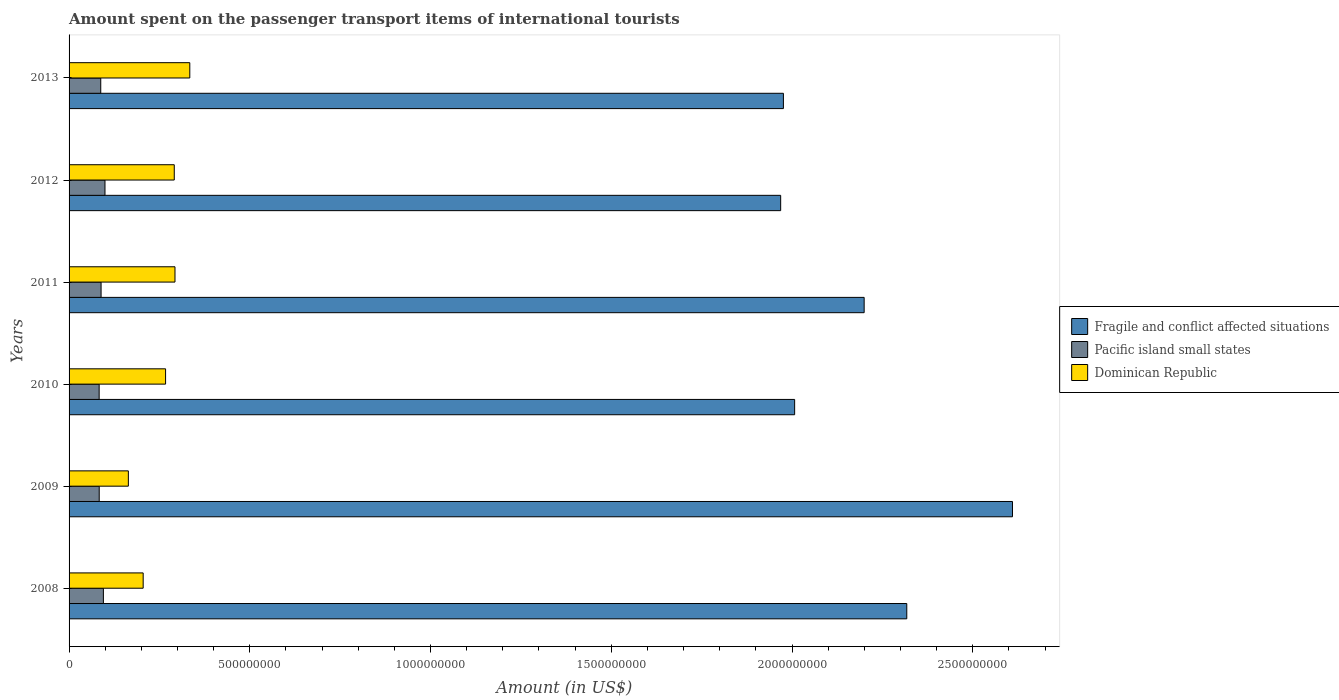How many different coloured bars are there?
Keep it short and to the point. 3. How many groups of bars are there?
Offer a terse response. 6. Are the number of bars per tick equal to the number of legend labels?
Provide a succinct answer. Yes. Are the number of bars on each tick of the Y-axis equal?
Ensure brevity in your answer.  Yes. How many bars are there on the 6th tick from the top?
Keep it short and to the point. 3. What is the label of the 3rd group of bars from the top?
Make the answer very short. 2011. In how many cases, is the number of bars for a given year not equal to the number of legend labels?
Make the answer very short. 0. What is the amount spent on the passenger transport items of international tourists in Pacific island small states in 2012?
Ensure brevity in your answer.  9.93e+07. Across all years, what is the maximum amount spent on the passenger transport items of international tourists in Pacific island small states?
Offer a very short reply. 9.93e+07. Across all years, what is the minimum amount spent on the passenger transport items of international tourists in Fragile and conflict affected situations?
Offer a terse response. 1.97e+09. In which year was the amount spent on the passenger transport items of international tourists in Dominican Republic minimum?
Ensure brevity in your answer.  2009. What is the total amount spent on the passenger transport items of international tourists in Fragile and conflict affected situations in the graph?
Ensure brevity in your answer.  1.31e+1. What is the difference between the amount spent on the passenger transport items of international tourists in Dominican Republic in 2008 and that in 2011?
Your answer should be compact. -8.80e+07. What is the difference between the amount spent on the passenger transport items of international tourists in Fragile and conflict affected situations in 2011 and the amount spent on the passenger transport items of international tourists in Dominican Republic in 2012?
Make the answer very short. 1.91e+09. What is the average amount spent on the passenger transport items of international tourists in Fragile and conflict affected situations per year?
Your response must be concise. 2.18e+09. In the year 2012, what is the difference between the amount spent on the passenger transport items of international tourists in Dominican Republic and amount spent on the passenger transport items of international tourists in Pacific island small states?
Give a very brief answer. 1.92e+08. In how many years, is the amount spent on the passenger transport items of international tourists in Pacific island small states greater than 400000000 US$?
Offer a very short reply. 0. What is the ratio of the amount spent on the passenger transport items of international tourists in Dominican Republic in 2011 to that in 2012?
Your response must be concise. 1.01. Is the difference between the amount spent on the passenger transport items of international tourists in Dominican Republic in 2010 and 2011 greater than the difference between the amount spent on the passenger transport items of international tourists in Pacific island small states in 2010 and 2011?
Keep it short and to the point. No. What is the difference between the highest and the second highest amount spent on the passenger transport items of international tourists in Pacific island small states?
Provide a short and direct response. 4.42e+06. What is the difference between the highest and the lowest amount spent on the passenger transport items of international tourists in Fragile and conflict affected situations?
Give a very brief answer. 6.41e+08. In how many years, is the amount spent on the passenger transport items of international tourists in Pacific island small states greater than the average amount spent on the passenger transport items of international tourists in Pacific island small states taken over all years?
Your answer should be very brief. 2. What does the 1st bar from the top in 2010 represents?
Ensure brevity in your answer.  Dominican Republic. What does the 3rd bar from the bottom in 2008 represents?
Keep it short and to the point. Dominican Republic. Are all the bars in the graph horizontal?
Provide a succinct answer. Yes. What is the difference between two consecutive major ticks on the X-axis?
Ensure brevity in your answer.  5.00e+08. Does the graph contain grids?
Ensure brevity in your answer.  No. How many legend labels are there?
Provide a succinct answer. 3. How are the legend labels stacked?
Ensure brevity in your answer.  Vertical. What is the title of the graph?
Give a very brief answer. Amount spent on the passenger transport items of international tourists. What is the label or title of the X-axis?
Give a very brief answer. Amount (in US$). What is the Amount (in US$) of Fragile and conflict affected situations in 2008?
Your response must be concise. 2.32e+09. What is the Amount (in US$) of Pacific island small states in 2008?
Keep it short and to the point. 9.49e+07. What is the Amount (in US$) in Dominican Republic in 2008?
Ensure brevity in your answer.  2.05e+08. What is the Amount (in US$) in Fragile and conflict affected situations in 2009?
Your answer should be very brief. 2.61e+09. What is the Amount (in US$) in Pacific island small states in 2009?
Your answer should be compact. 8.34e+07. What is the Amount (in US$) in Dominican Republic in 2009?
Make the answer very short. 1.64e+08. What is the Amount (in US$) of Fragile and conflict affected situations in 2010?
Your response must be concise. 2.01e+09. What is the Amount (in US$) in Pacific island small states in 2010?
Offer a very short reply. 8.32e+07. What is the Amount (in US$) of Dominican Republic in 2010?
Give a very brief answer. 2.67e+08. What is the Amount (in US$) of Fragile and conflict affected situations in 2011?
Your response must be concise. 2.20e+09. What is the Amount (in US$) in Pacific island small states in 2011?
Offer a very short reply. 8.85e+07. What is the Amount (in US$) of Dominican Republic in 2011?
Provide a succinct answer. 2.93e+08. What is the Amount (in US$) in Fragile and conflict affected situations in 2012?
Provide a succinct answer. 1.97e+09. What is the Amount (in US$) in Pacific island small states in 2012?
Make the answer very short. 9.93e+07. What is the Amount (in US$) of Dominican Republic in 2012?
Your response must be concise. 2.91e+08. What is the Amount (in US$) in Fragile and conflict affected situations in 2013?
Give a very brief answer. 1.98e+09. What is the Amount (in US$) of Pacific island small states in 2013?
Keep it short and to the point. 8.76e+07. What is the Amount (in US$) in Dominican Republic in 2013?
Ensure brevity in your answer.  3.34e+08. Across all years, what is the maximum Amount (in US$) in Fragile and conflict affected situations?
Make the answer very short. 2.61e+09. Across all years, what is the maximum Amount (in US$) in Pacific island small states?
Provide a short and direct response. 9.93e+07. Across all years, what is the maximum Amount (in US$) in Dominican Republic?
Offer a very short reply. 3.34e+08. Across all years, what is the minimum Amount (in US$) of Fragile and conflict affected situations?
Your response must be concise. 1.97e+09. Across all years, what is the minimum Amount (in US$) in Pacific island small states?
Your answer should be very brief. 8.32e+07. Across all years, what is the minimum Amount (in US$) of Dominican Republic?
Offer a terse response. 1.64e+08. What is the total Amount (in US$) of Fragile and conflict affected situations in the graph?
Give a very brief answer. 1.31e+1. What is the total Amount (in US$) of Pacific island small states in the graph?
Offer a very short reply. 5.37e+08. What is the total Amount (in US$) of Dominican Republic in the graph?
Make the answer very short. 1.55e+09. What is the difference between the Amount (in US$) of Fragile and conflict affected situations in 2008 and that in 2009?
Provide a succinct answer. -2.92e+08. What is the difference between the Amount (in US$) of Pacific island small states in 2008 and that in 2009?
Offer a terse response. 1.15e+07. What is the difference between the Amount (in US$) in Dominican Republic in 2008 and that in 2009?
Your answer should be compact. 4.10e+07. What is the difference between the Amount (in US$) of Fragile and conflict affected situations in 2008 and that in 2010?
Offer a terse response. 3.10e+08. What is the difference between the Amount (in US$) of Pacific island small states in 2008 and that in 2010?
Your response must be concise. 1.17e+07. What is the difference between the Amount (in US$) in Dominican Republic in 2008 and that in 2010?
Give a very brief answer. -6.20e+07. What is the difference between the Amount (in US$) in Fragile and conflict affected situations in 2008 and that in 2011?
Your answer should be compact. 1.18e+08. What is the difference between the Amount (in US$) in Pacific island small states in 2008 and that in 2011?
Provide a short and direct response. 6.38e+06. What is the difference between the Amount (in US$) of Dominican Republic in 2008 and that in 2011?
Ensure brevity in your answer.  -8.80e+07. What is the difference between the Amount (in US$) of Fragile and conflict affected situations in 2008 and that in 2012?
Ensure brevity in your answer.  3.49e+08. What is the difference between the Amount (in US$) in Pacific island small states in 2008 and that in 2012?
Ensure brevity in your answer.  -4.42e+06. What is the difference between the Amount (in US$) of Dominican Republic in 2008 and that in 2012?
Make the answer very short. -8.60e+07. What is the difference between the Amount (in US$) in Fragile and conflict affected situations in 2008 and that in 2013?
Offer a very short reply. 3.41e+08. What is the difference between the Amount (in US$) of Pacific island small states in 2008 and that in 2013?
Provide a succinct answer. 7.29e+06. What is the difference between the Amount (in US$) of Dominican Republic in 2008 and that in 2013?
Give a very brief answer. -1.29e+08. What is the difference between the Amount (in US$) of Fragile and conflict affected situations in 2009 and that in 2010?
Provide a succinct answer. 6.03e+08. What is the difference between the Amount (in US$) in Pacific island small states in 2009 and that in 2010?
Ensure brevity in your answer.  1.92e+05. What is the difference between the Amount (in US$) of Dominican Republic in 2009 and that in 2010?
Keep it short and to the point. -1.03e+08. What is the difference between the Amount (in US$) of Fragile and conflict affected situations in 2009 and that in 2011?
Provide a short and direct response. 4.10e+08. What is the difference between the Amount (in US$) in Pacific island small states in 2009 and that in 2011?
Ensure brevity in your answer.  -5.13e+06. What is the difference between the Amount (in US$) of Dominican Republic in 2009 and that in 2011?
Your answer should be compact. -1.29e+08. What is the difference between the Amount (in US$) in Fragile and conflict affected situations in 2009 and that in 2012?
Offer a very short reply. 6.41e+08. What is the difference between the Amount (in US$) of Pacific island small states in 2009 and that in 2012?
Your answer should be compact. -1.59e+07. What is the difference between the Amount (in US$) in Dominican Republic in 2009 and that in 2012?
Provide a short and direct response. -1.27e+08. What is the difference between the Amount (in US$) of Fragile and conflict affected situations in 2009 and that in 2013?
Ensure brevity in your answer.  6.34e+08. What is the difference between the Amount (in US$) in Pacific island small states in 2009 and that in 2013?
Offer a terse response. -4.22e+06. What is the difference between the Amount (in US$) in Dominican Republic in 2009 and that in 2013?
Make the answer very short. -1.70e+08. What is the difference between the Amount (in US$) in Fragile and conflict affected situations in 2010 and that in 2011?
Make the answer very short. -1.92e+08. What is the difference between the Amount (in US$) of Pacific island small states in 2010 and that in 2011?
Your response must be concise. -5.32e+06. What is the difference between the Amount (in US$) in Dominican Republic in 2010 and that in 2011?
Give a very brief answer. -2.60e+07. What is the difference between the Amount (in US$) in Fragile and conflict affected situations in 2010 and that in 2012?
Your answer should be compact. 3.86e+07. What is the difference between the Amount (in US$) in Pacific island small states in 2010 and that in 2012?
Provide a short and direct response. -1.61e+07. What is the difference between the Amount (in US$) of Dominican Republic in 2010 and that in 2012?
Offer a very short reply. -2.40e+07. What is the difference between the Amount (in US$) of Fragile and conflict affected situations in 2010 and that in 2013?
Provide a short and direct response. 3.11e+07. What is the difference between the Amount (in US$) in Pacific island small states in 2010 and that in 2013?
Ensure brevity in your answer.  -4.41e+06. What is the difference between the Amount (in US$) in Dominican Republic in 2010 and that in 2013?
Your answer should be very brief. -6.70e+07. What is the difference between the Amount (in US$) in Fragile and conflict affected situations in 2011 and that in 2012?
Keep it short and to the point. 2.31e+08. What is the difference between the Amount (in US$) in Pacific island small states in 2011 and that in 2012?
Offer a very short reply. -1.08e+07. What is the difference between the Amount (in US$) of Dominican Republic in 2011 and that in 2012?
Offer a very short reply. 2.00e+06. What is the difference between the Amount (in US$) of Fragile and conflict affected situations in 2011 and that in 2013?
Provide a short and direct response. 2.23e+08. What is the difference between the Amount (in US$) in Pacific island small states in 2011 and that in 2013?
Offer a very short reply. 9.12e+05. What is the difference between the Amount (in US$) of Dominican Republic in 2011 and that in 2013?
Keep it short and to the point. -4.10e+07. What is the difference between the Amount (in US$) in Fragile and conflict affected situations in 2012 and that in 2013?
Your answer should be very brief. -7.56e+06. What is the difference between the Amount (in US$) in Pacific island small states in 2012 and that in 2013?
Your answer should be compact. 1.17e+07. What is the difference between the Amount (in US$) of Dominican Republic in 2012 and that in 2013?
Give a very brief answer. -4.30e+07. What is the difference between the Amount (in US$) in Fragile and conflict affected situations in 2008 and the Amount (in US$) in Pacific island small states in 2009?
Offer a very short reply. 2.23e+09. What is the difference between the Amount (in US$) of Fragile and conflict affected situations in 2008 and the Amount (in US$) of Dominican Republic in 2009?
Ensure brevity in your answer.  2.15e+09. What is the difference between the Amount (in US$) in Pacific island small states in 2008 and the Amount (in US$) in Dominican Republic in 2009?
Provide a succinct answer. -6.91e+07. What is the difference between the Amount (in US$) in Fragile and conflict affected situations in 2008 and the Amount (in US$) in Pacific island small states in 2010?
Ensure brevity in your answer.  2.23e+09. What is the difference between the Amount (in US$) of Fragile and conflict affected situations in 2008 and the Amount (in US$) of Dominican Republic in 2010?
Offer a terse response. 2.05e+09. What is the difference between the Amount (in US$) of Pacific island small states in 2008 and the Amount (in US$) of Dominican Republic in 2010?
Your answer should be very brief. -1.72e+08. What is the difference between the Amount (in US$) in Fragile and conflict affected situations in 2008 and the Amount (in US$) in Pacific island small states in 2011?
Your answer should be very brief. 2.23e+09. What is the difference between the Amount (in US$) of Fragile and conflict affected situations in 2008 and the Amount (in US$) of Dominican Republic in 2011?
Your response must be concise. 2.02e+09. What is the difference between the Amount (in US$) of Pacific island small states in 2008 and the Amount (in US$) of Dominican Republic in 2011?
Keep it short and to the point. -1.98e+08. What is the difference between the Amount (in US$) of Fragile and conflict affected situations in 2008 and the Amount (in US$) of Pacific island small states in 2012?
Offer a very short reply. 2.22e+09. What is the difference between the Amount (in US$) in Fragile and conflict affected situations in 2008 and the Amount (in US$) in Dominican Republic in 2012?
Make the answer very short. 2.03e+09. What is the difference between the Amount (in US$) of Pacific island small states in 2008 and the Amount (in US$) of Dominican Republic in 2012?
Ensure brevity in your answer.  -1.96e+08. What is the difference between the Amount (in US$) of Fragile and conflict affected situations in 2008 and the Amount (in US$) of Pacific island small states in 2013?
Offer a terse response. 2.23e+09. What is the difference between the Amount (in US$) of Fragile and conflict affected situations in 2008 and the Amount (in US$) of Dominican Republic in 2013?
Offer a very short reply. 1.98e+09. What is the difference between the Amount (in US$) in Pacific island small states in 2008 and the Amount (in US$) in Dominican Republic in 2013?
Your answer should be compact. -2.39e+08. What is the difference between the Amount (in US$) in Fragile and conflict affected situations in 2009 and the Amount (in US$) in Pacific island small states in 2010?
Your response must be concise. 2.53e+09. What is the difference between the Amount (in US$) in Fragile and conflict affected situations in 2009 and the Amount (in US$) in Dominican Republic in 2010?
Your answer should be very brief. 2.34e+09. What is the difference between the Amount (in US$) of Pacific island small states in 2009 and the Amount (in US$) of Dominican Republic in 2010?
Ensure brevity in your answer.  -1.84e+08. What is the difference between the Amount (in US$) in Fragile and conflict affected situations in 2009 and the Amount (in US$) in Pacific island small states in 2011?
Your answer should be very brief. 2.52e+09. What is the difference between the Amount (in US$) of Fragile and conflict affected situations in 2009 and the Amount (in US$) of Dominican Republic in 2011?
Make the answer very short. 2.32e+09. What is the difference between the Amount (in US$) of Pacific island small states in 2009 and the Amount (in US$) of Dominican Republic in 2011?
Your answer should be compact. -2.10e+08. What is the difference between the Amount (in US$) in Fragile and conflict affected situations in 2009 and the Amount (in US$) in Pacific island small states in 2012?
Make the answer very short. 2.51e+09. What is the difference between the Amount (in US$) of Fragile and conflict affected situations in 2009 and the Amount (in US$) of Dominican Republic in 2012?
Your answer should be compact. 2.32e+09. What is the difference between the Amount (in US$) of Pacific island small states in 2009 and the Amount (in US$) of Dominican Republic in 2012?
Provide a succinct answer. -2.08e+08. What is the difference between the Amount (in US$) in Fragile and conflict affected situations in 2009 and the Amount (in US$) in Pacific island small states in 2013?
Make the answer very short. 2.52e+09. What is the difference between the Amount (in US$) in Fragile and conflict affected situations in 2009 and the Amount (in US$) in Dominican Republic in 2013?
Keep it short and to the point. 2.28e+09. What is the difference between the Amount (in US$) in Pacific island small states in 2009 and the Amount (in US$) in Dominican Republic in 2013?
Offer a very short reply. -2.51e+08. What is the difference between the Amount (in US$) of Fragile and conflict affected situations in 2010 and the Amount (in US$) of Pacific island small states in 2011?
Your answer should be compact. 1.92e+09. What is the difference between the Amount (in US$) in Fragile and conflict affected situations in 2010 and the Amount (in US$) in Dominican Republic in 2011?
Your answer should be very brief. 1.71e+09. What is the difference between the Amount (in US$) of Pacific island small states in 2010 and the Amount (in US$) of Dominican Republic in 2011?
Your answer should be very brief. -2.10e+08. What is the difference between the Amount (in US$) in Fragile and conflict affected situations in 2010 and the Amount (in US$) in Pacific island small states in 2012?
Ensure brevity in your answer.  1.91e+09. What is the difference between the Amount (in US$) in Fragile and conflict affected situations in 2010 and the Amount (in US$) in Dominican Republic in 2012?
Provide a succinct answer. 1.72e+09. What is the difference between the Amount (in US$) of Pacific island small states in 2010 and the Amount (in US$) of Dominican Republic in 2012?
Give a very brief answer. -2.08e+08. What is the difference between the Amount (in US$) of Fragile and conflict affected situations in 2010 and the Amount (in US$) of Pacific island small states in 2013?
Give a very brief answer. 1.92e+09. What is the difference between the Amount (in US$) of Fragile and conflict affected situations in 2010 and the Amount (in US$) of Dominican Republic in 2013?
Provide a succinct answer. 1.67e+09. What is the difference between the Amount (in US$) of Pacific island small states in 2010 and the Amount (in US$) of Dominican Republic in 2013?
Your response must be concise. -2.51e+08. What is the difference between the Amount (in US$) in Fragile and conflict affected situations in 2011 and the Amount (in US$) in Pacific island small states in 2012?
Ensure brevity in your answer.  2.10e+09. What is the difference between the Amount (in US$) of Fragile and conflict affected situations in 2011 and the Amount (in US$) of Dominican Republic in 2012?
Ensure brevity in your answer.  1.91e+09. What is the difference between the Amount (in US$) of Pacific island small states in 2011 and the Amount (in US$) of Dominican Republic in 2012?
Ensure brevity in your answer.  -2.02e+08. What is the difference between the Amount (in US$) in Fragile and conflict affected situations in 2011 and the Amount (in US$) in Pacific island small states in 2013?
Give a very brief answer. 2.11e+09. What is the difference between the Amount (in US$) in Fragile and conflict affected situations in 2011 and the Amount (in US$) in Dominican Republic in 2013?
Your answer should be very brief. 1.87e+09. What is the difference between the Amount (in US$) of Pacific island small states in 2011 and the Amount (in US$) of Dominican Republic in 2013?
Your answer should be compact. -2.45e+08. What is the difference between the Amount (in US$) of Fragile and conflict affected situations in 2012 and the Amount (in US$) of Pacific island small states in 2013?
Offer a very short reply. 1.88e+09. What is the difference between the Amount (in US$) of Fragile and conflict affected situations in 2012 and the Amount (in US$) of Dominican Republic in 2013?
Offer a terse response. 1.63e+09. What is the difference between the Amount (in US$) of Pacific island small states in 2012 and the Amount (in US$) of Dominican Republic in 2013?
Ensure brevity in your answer.  -2.35e+08. What is the average Amount (in US$) in Fragile and conflict affected situations per year?
Provide a short and direct response. 2.18e+09. What is the average Amount (in US$) in Pacific island small states per year?
Keep it short and to the point. 8.95e+07. What is the average Amount (in US$) in Dominican Republic per year?
Keep it short and to the point. 2.59e+08. In the year 2008, what is the difference between the Amount (in US$) of Fragile and conflict affected situations and Amount (in US$) of Pacific island small states?
Give a very brief answer. 2.22e+09. In the year 2008, what is the difference between the Amount (in US$) of Fragile and conflict affected situations and Amount (in US$) of Dominican Republic?
Your answer should be very brief. 2.11e+09. In the year 2008, what is the difference between the Amount (in US$) in Pacific island small states and Amount (in US$) in Dominican Republic?
Offer a very short reply. -1.10e+08. In the year 2009, what is the difference between the Amount (in US$) in Fragile and conflict affected situations and Amount (in US$) in Pacific island small states?
Your answer should be very brief. 2.53e+09. In the year 2009, what is the difference between the Amount (in US$) in Fragile and conflict affected situations and Amount (in US$) in Dominican Republic?
Your response must be concise. 2.45e+09. In the year 2009, what is the difference between the Amount (in US$) of Pacific island small states and Amount (in US$) of Dominican Republic?
Keep it short and to the point. -8.06e+07. In the year 2010, what is the difference between the Amount (in US$) of Fragile and conflict affected situations and Amount (in US$) of Pacific island small states?
Provide a succinct answer. 1.92e+09. In the year 2010, what is the difference between the Amount (in US$) in Fragile and conflict affected situations and Amount (in US$) in Dominican Republic?
Your response must be concise. 1.74e+09. In the year 2010, what is the difference between the Amount (in US$) in Pacific island small states and Amount (in US$) in Dominican Republic?
Offer a very short reply. -1.84e+08. In the year 2011, what is the difference between the Amount (in US$) in Fragile and conflict affected situations and Amount (in US$) in Pacific island small states?
Ensure brevity in your answer.  2.11e+09. In the year 2011, what is the difference between the Amount (in US$) of Fragile and conflict affected situations and Amount (in US$) of Dominican Republic?
Offer a very short reply. 1.91e+09. In the year 2011, what is the difference between the Amount (in US$) of Pacific island small states and Amount (in US$) of Dominican Republic?
Provide a succinct answer. -2.04e+08. In the year 2012, what is the difference between the Amount (in US$) of Fragile and conflict affected situations and Amount (in US$) of Pacific island small states?
Offer a very short reply. 1.87e+09. In the year 2012, what is the difference between the Amount (in US$) in Fragile and conflict affected situations and Amount (in US$) in Dominican Republic?
Make the answer very short. 1.68e+09. In the year 2012, what is the difference between the Amount (in US$) of Pacific island small states and Amount (in US$) of Dominican Republic?
Keep it short and to the point. -1.92e+08. In the year 2013, what is the difference between the Amount (in US$) of Fragile and conflict affected situations and Amount (in US$) of Pacific island small states?
Ensure brevity in your answer.  1.89e+09. In the year 2013, what is the difference between the Amount (in US$) in Fragile and conflict affected situations and Amount (in US$) in Dominican Republic?
Give a very brief answer. 1.64e+09. In the year 2013, what is the difference between the Amount (in US$) of Pacific island small states and Amount (in US$) of Dominican Republic?
Your answer should be very brief. -2.46e+08. What is the ratio of the Amount (in US$) in Fragile and conflict affected situations in 2008 to that in 2009?
Make the answer very short. 0.89. What is the ratio of the Amount (in US$) of Pacific island small states in 2008 to that in 2009?
Your answer should be compact. 1.14. What is the ratio of the Amount (in US$) in Dominican Republic in 2008 to that in 2009?
Offer a terse response. 1.25. What is the ratio of the Amount (in US$) in Fragile and conflict affected situations in 2008 to that in 2010?
Provide a short and direct response. 1.15. What is the ratio of the Amount (in US$) in Pacific island small states in 2008 to that in 2010?
Your answer should be very brief. 1.14. What is the ratio of the Amount (in US$) in Dominican Republic in 2008 to that in 2010?
Offer a very short reply. 0.77. What is the ratio of the Amount (in US$) of Fragile and conflict affected situations in 2008 to that in 2011?
Keep it short and to the point. 1.05. What is the ratio of the Amount (in US$) in Pacific island small states in 2008 to that in 2011?
Keep it short and to the point. 1.07. What is the ratio of the Amount (in US$) of Dominican Republic in 2008 to that in 2011?
Provide a succinct answer. 0.7. What is the ratio of the Amount (in US$) of Fragile and conflict affected situations in 2008 to that in 2012?
Your answer should be very brief. 1.18. What is the ratio of the Amount (in US$) in Pacific island small states in 2008 to that in 2012?
Your answer should be compact. 0.96. What is the ratio of the Amount (in US$) of Dominican Republic in 2008 to that in 2012?
Provide a short and direct response. 0.7. What is the ratio of the Amount (in US$) of Fragile and conflict affected situations in 2008 to that in 2013?
Ensure brevity in your answer.  1.17. What is the ratio of the Amount (in US$) in Pacific island small states in 2008 to that in 2013?
Your answer should be very brief. 1.08. What is the ratio of the Amount (in US$) in Dominican Republic in 2008 to that in 2013?
Provide a short and direct response. 0.61. What is the ratio of the Amount (in US$) in Fragile and conflict affected situations in 2009 to that in 2010?
Your answer should be very brief. 1.3. What is the ratio of the Amount (in US$) in Pacific island small states in 2009 to that in 2010?
Offer a terse response. 1. What is the ratio of the Amount (in US$) of Dominican Republic in 2009 to that in 2010?
Make the answer very short. 0.61. What is the ratio of the Amount (in US$) of Fragile and conflict affected situations in 2009 to that in 2011?
Your answer should be compact. 1.19. What is the ratio of the Amount (in US$) in Pacific island small states in 2009 to that in 2011?
Your answer should be compact. 0.94. What is the ratio of the Amount (in US$) of Dominican Republic in 2009 to that in 2011?
Provide a succinct answer. 0.56. What is the ratio of the Amount (in US$) in Fragile and conflict affected situations in 2009 to that in 2012?
Keep it short and to the point. 1.33. What is the ratio of the Amount (in US$) in Pacific island small states in 2009 to that in 2012?
Give a very brief answer. 0.84. What is the ratio of the Amount (in US$) of Dominican Republic in 2009 to that in 2012?
Offer a very short reply. 0.56. What is the ratio of the Amount (in US$) in Fragile and conflict affected situations in 2009 to that in 2013?
Your answer should be compact. 1.32. What is the ratio of the Amount (in US$) in Pacific island small states in 2009 to that in 2013?
Offer a very short reply. 0.95. What is the ratio of the Amount (in US$) in Dominican Republic in 2009 to that in 2013?
Ensure brevity in your answer.  0.49. What is the ratio of the Amount (in US$) of Fragile and conflict affected situations in 2010 to that in 2011?
Offer a terse response. 0.91. What is the ratio of the Amount (in US$) in Pacific island small states in 2010 to that in 2011?
Your answer should be very brief. 0.94. What is the ratio of the Amount (in US$) in Dominican Republic in 2010 to that in 2011?
Provide a short and direct response. 0.91. What is the ratio of the Amount (in US$) in Fragile and conflict affected situations in 2010 to that in 2012?
Provide a short and direct response. 1.02. What is the ratio of the Amount (in US$) in Pacific island small states in 2010 to that in 2012?
Your response must be concise. 0.84. What is the ratio of the Amount (in US$) in Dominican Republic in 2010 to that in 2012?
Provide a succinct answer. 0.92. What is the ratio of the Amount (in US$) of Fragile and conflict affected situations in 2010 to that in 2013?
Your answer should be compact. 1.02. What is the ratio of the Amount (in US$) in Pacific island small states in 2010 to that in 2013?
Your answer should be very brief. 0.95. What is the ratio of the Amount (in US$) in Dominican Republic in 2010 to that in 2013?
Give a very brief answer. 0.8. What is the ratio of the Amount (in US$) in Fragile and conflict affected situations in 2011 to that in 2012?
Provide a short and direct response. 1.12. What is the ratio of the Amount (in US$) of Pacific island small states in 2011 to that in 2012?
Make the answer very short. 0.89. What is the ratio of the Amount (in US$) in Fragile and conflict affected situations in 2011 to that in 2013?
Make the answer very short. 1.11. What is the ratio of the Amount (in US$) in Pacific island small states in 2011 to that in 2013?
Keep it short and to the point. 1.01. What is the ratio of the Amount (in US$) in Dominican Republic in 2011 to that in 2013?
Offer a very short reply. 0.88. What is the ratio of the Amount (in US$) of Pacific island small states in 2012 to that in 2013?
Keep it short and to the point. 1.13. What is the ratio of the Amount (in US$) of Dominican Republic in 2012 to that in 2013?
Give a very brief answer. 0.87. What is the difference between the highest and the second highest Amount (in US$) in Fragile and conflict affected situations?
Ensure brevity in your answer.  2.92e+08. What is the difference between the highest and the second highest Amount (in US$) of Pacific island small states?
Give a very brief answer. 4.42e+06. What is the difference between the highest and the second highest Amount (in US$) in Dominican Republic?
Ensure brevity in your answer.  4.10e+07. What is the difference between the highest and the lowest Amount (in US$) of Fragile and conflict affected situations?
Provide a short and direct response. 6.41e+08. What is the difference between the highest and the lowest Amount (in US$) in Pacific island small states?
Provide a short and direct response. 1.61e+07. What is the difference between the highest and the lowest Amount (in US$) in Dominican Republic?
Provide a succinct answer. 1.70e+08. 